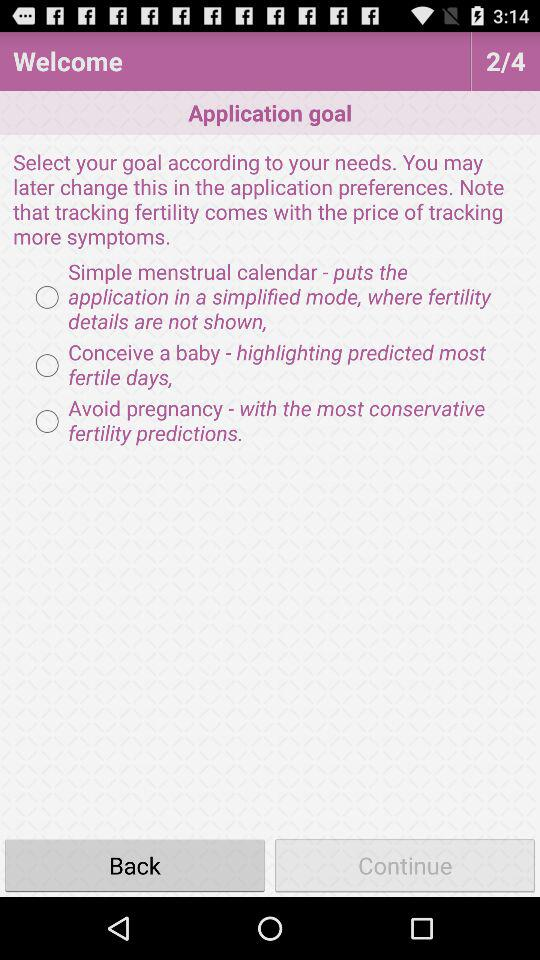Which tab has been enable?
When the provided information is insufficient, respond with <no answer>. <no answer> 